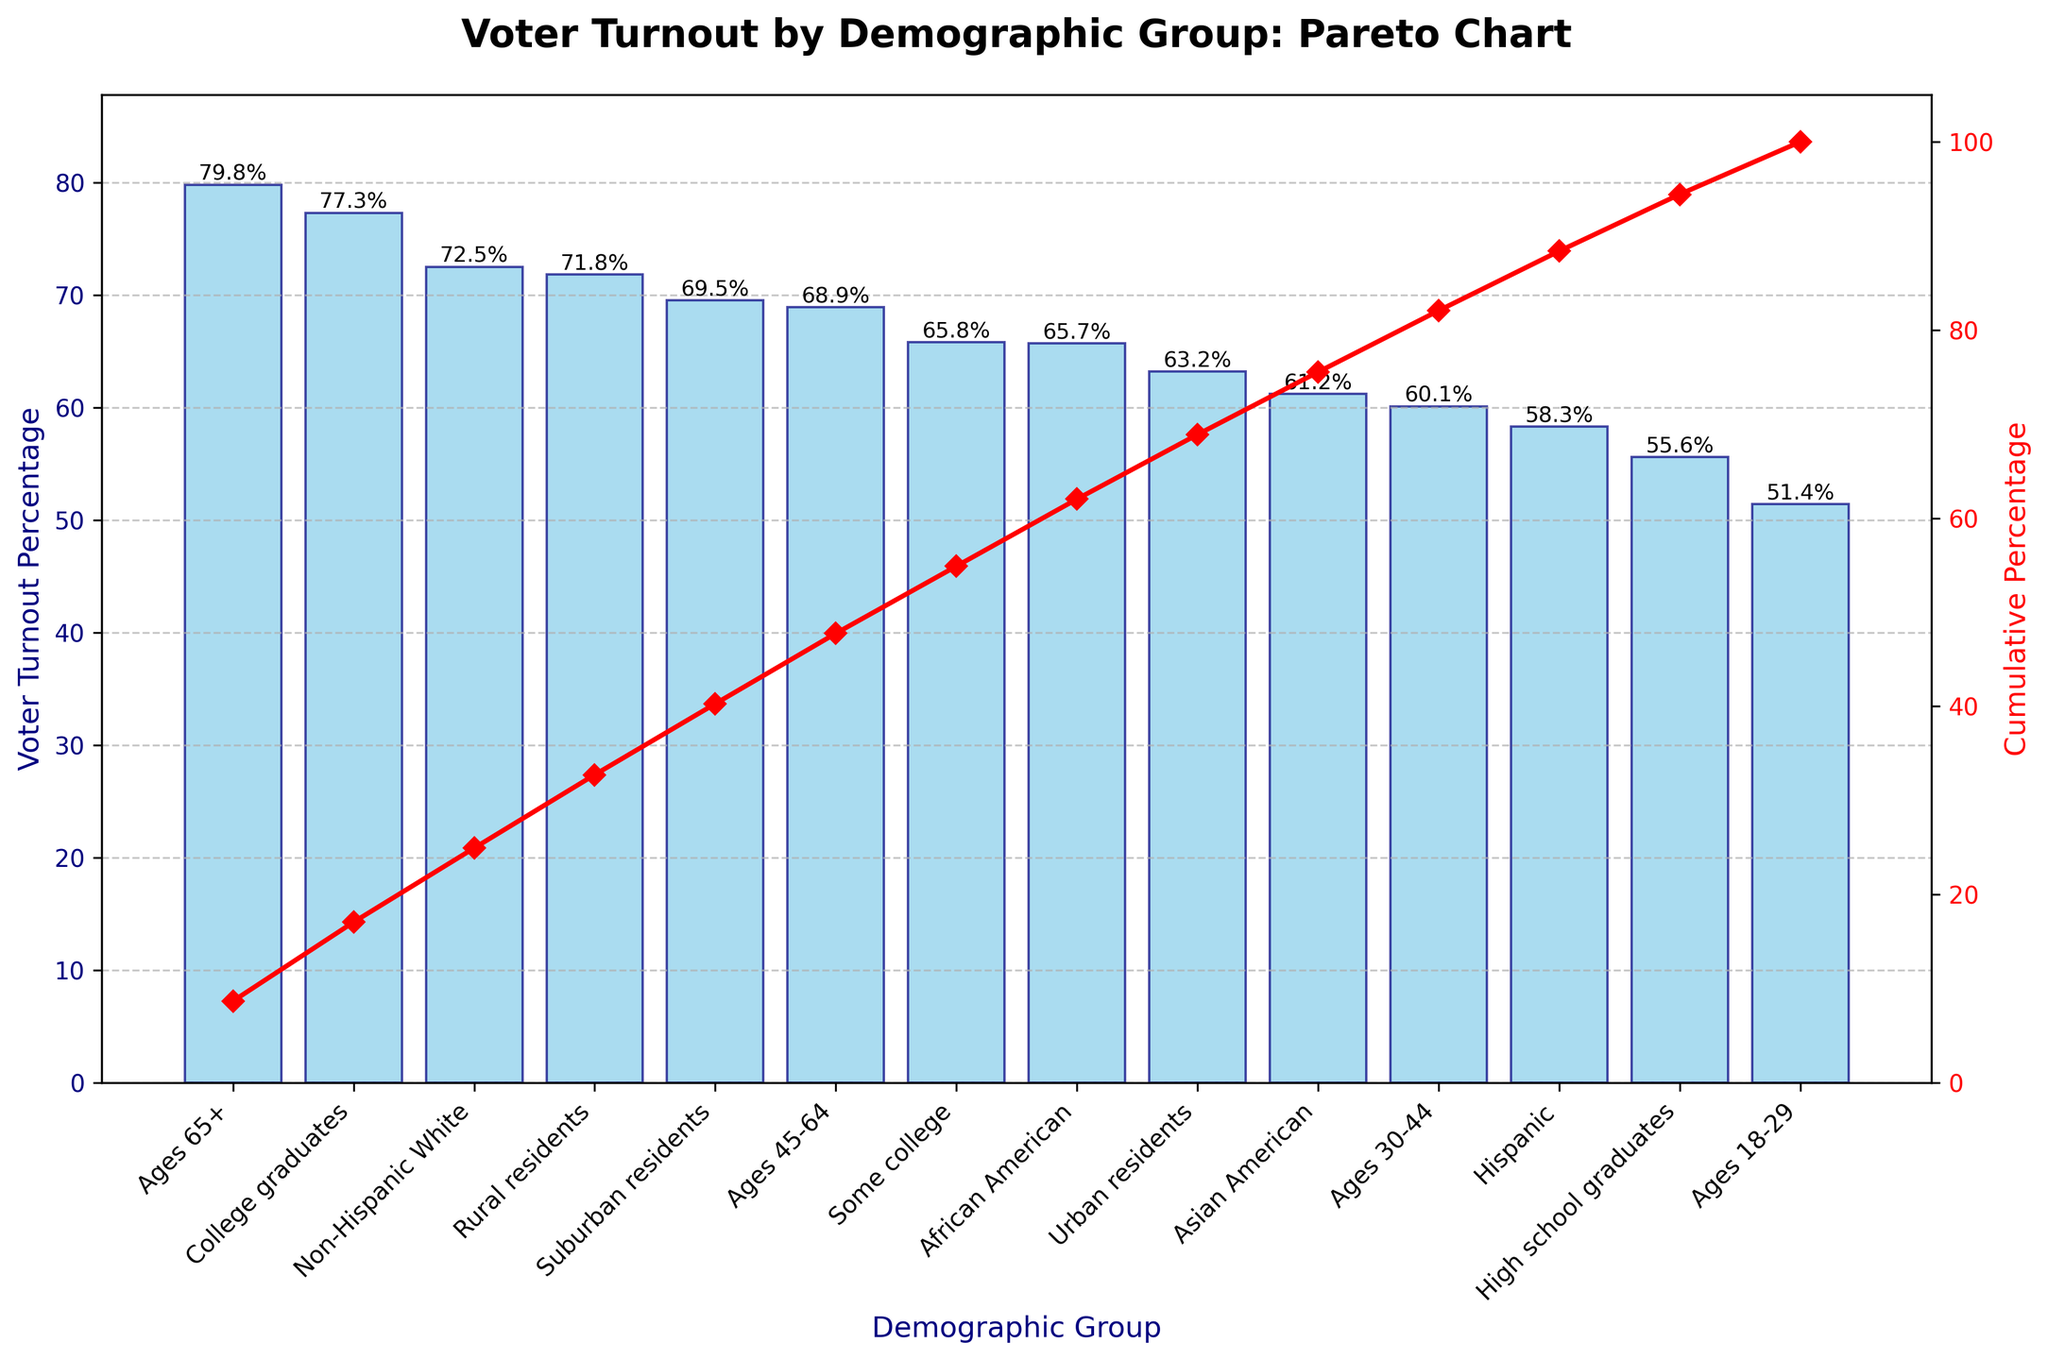What is the title of the figure? The title is usually written at the top of the chart. In this case, it reads, "Voter Turnout by Demographic Group: Pareto Chart".
Answer: Voter Turnout by Demographic Group: Pareto Chart Which demographic group has the highest voter turnout percentage? By examining the bars, the demographic group with the highest bar indicates the highest voter turnout percentage. The Ages 65+ group has the tallest bar at 79.8%.
Answer: Ages 65+ What is the color of the bars representing voter turnout percentages? The color of the bars is described in the plot creation as "skyblue" with "navy" edges. Visually, the bars appear in a light blue shade.
Answer: Light blue (skyblue) What is the cumulative percentage corresponding to Non-Hispanic Whites? To determine the cumulative percentage, refer to the red line plot. For Non-Hispanic Whites, the cumulative percentage can be found from the point on the red line directly above the corresponding bar.
Answer: (Depends on the precise point but judging from context, it could be about 20-30%) Which group has a higher voter turnout percentage: High school graduates or Urban residents? Compare the bar heights for High school graduates and Urban residents. The height of the Urban residents' bar is higher than that of High school graduates' bar.
Answer: Urban residents What is the median voter turnout percentage value among all demographic groups? To find the median, list all voter turnout percentages in ascending order and locate the middle value. The sorted percentages are: 51.4, 55.6, 58.3, 60.1, 61.2, 63.2, 65.7, 65.8, 68.9, 69.5, 71.8, 72.5, 77.3, 79.8. The middle values are 65.7 and 65.8, so the median is the average of these two.
Answer: 65.75 How many demographic groups have a voter turnout percentage above 70%? Count all the bars that have heights representing percentages above 70%. The groups are Non-Hispanic White, Ages 65+, College graduates, and Rural residents.
Answer: 4 By how many percentage points is the voter turnout rate of College graduates higher than some college? Subtract the turnout rate of some college (65.8%) from college graduates (77.3%). 77.3% - 65.8% = 11.5%.
Answer: 11.5 Which demographic groups have a voter turnout percentage less than the overall average? First, calculate the average voter turnout percentage. Sum all percentages and divide by the number of demographic groups, then identify which percentages fall below this average. Sum: 72.5+58.3+65.7+61.2+79.8+68.9+60.1+51.4+77.3+65.8+55.6+63.2+69.5+71.8 = 971.1. Average: 971.1/14 = ~69.36%. Groups below this average are Hispanic, Asian American, Ages 30-44, Ages 18-29, High school graduates, Urban residents.
Answer: 6 groups (Hispanic, Asian American, Ages 30-44, Ages 18-29, High school graduates, Urban residents) What is the cumulative percentage for ages 45-64? Look at the point on the red cumulative percentage line that is directly above the Ages 45-64 bar. The exact value would need to be read off from the figure.
Answer: (Read from the figure) How does the cumulative percentage help in understanding the data in the Pareto chart? The cumulative percentage line helps illustrate the cumulative effect of adding each subsequent demographic group. It helps identify which groups contribute most significantly towards the overall voter turnout percentage. For example, we can see how quickly the cumulative percentage rises with the first few groups, indicating where the most significant contributions come from.
Answer: It shows the cumulative contribution of each group to the total voter turnout 